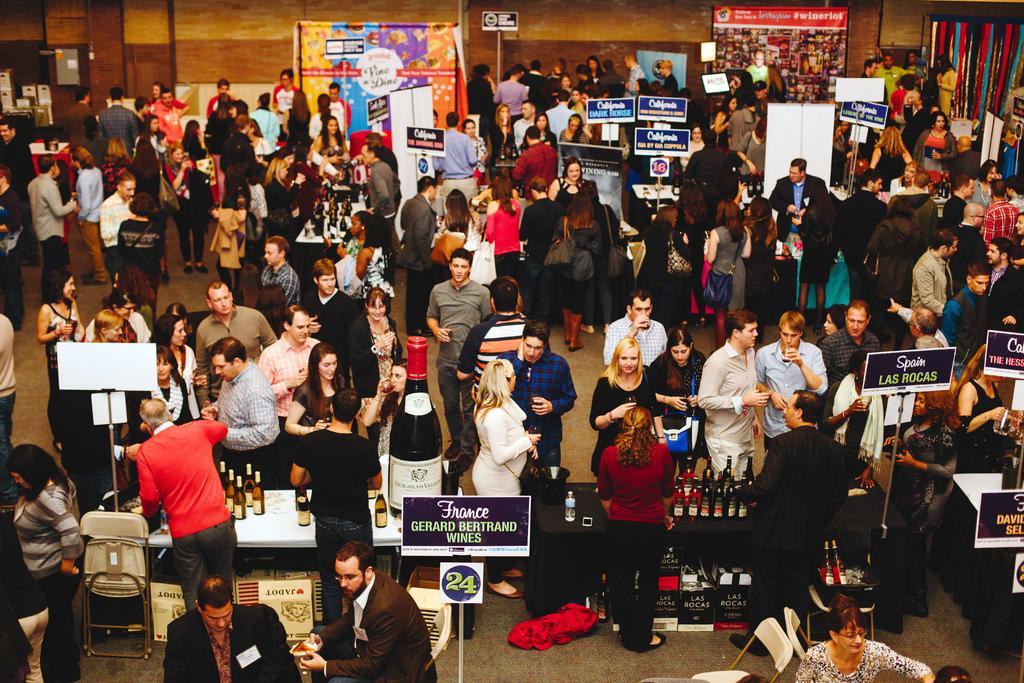Can you describe this image briefly? In the foreground of this image, there are people standing on the floor and we can see bottles on the tables and also few boards. In the background, there are banners, few objects and the wall. 